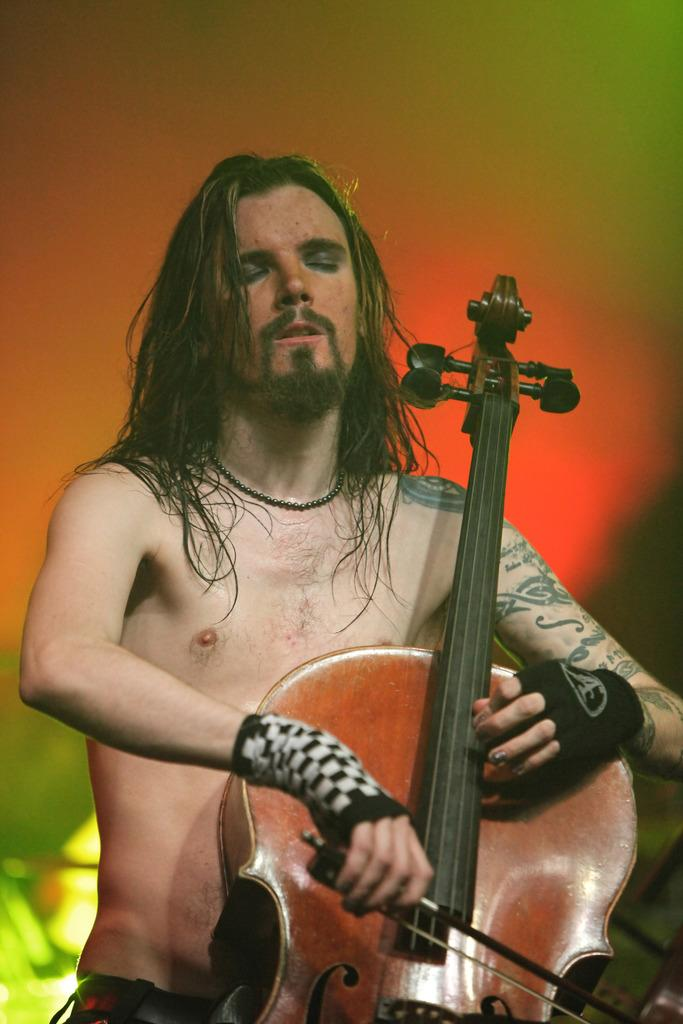Who is the main subject in the image? There is a man in the image. Can you describe the man's appearance? The man has short hair. What is the man holding in the image? The man is holding a guitar. What is the man doing with the guitar? The man is holding two bands in his hands. What type of bone can be seen in the man's hands in the image? There is no bone present in the image; the man is holding a guitar and two bands. How many sisters does the man have in the image? There is no information about the man's sisters in the image. 